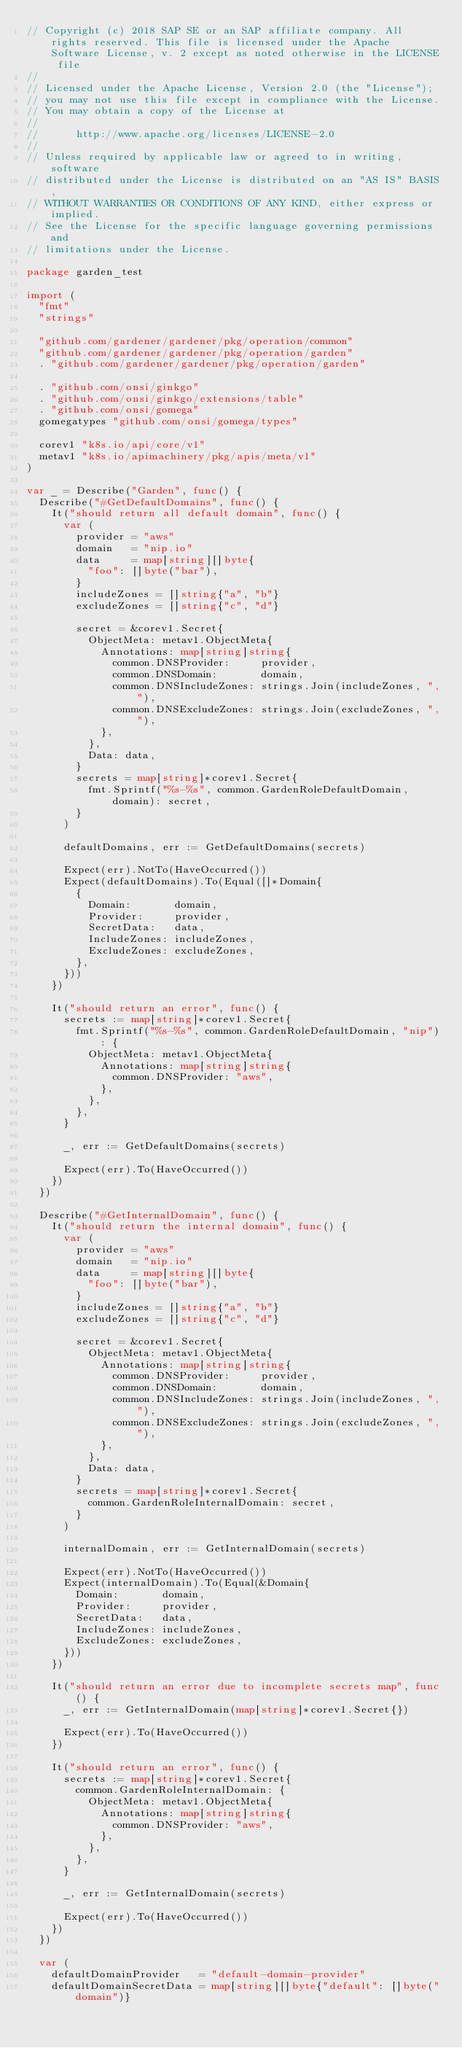<code> <loc_0><loc_0><loc_500><loc_500><_Go_>// Copyright (c) 2018 SAP SE or an SAP affiliate company. All rights reserved. This file is licensed under the Apache Software License, v. 2 except as noted otherwise in the LICENSE file
//
// Licensed under the Apache License, Version 2.0 (the "License");
// you may not use this file except in compliance with the License.
// You may obtain a copy of the License at
//
//      http://www.apache.org/licenses/LICENSE-2.0
//
// Unless required by applicable law or agreed to in writing, software
// distributed under the License is distributed on an "AS IS" BASIS,
// WITHOUT WARRANTIES OR CONDITIONS OF ANY KIND, either express or implied.
// See the License for the specific language governing permissions and
// limitations under the License.

package garden_test

import (
	"fmt"
	"strings"

	"github.com/gardener/gardener/pkg/operation/common"
	"github.com/gardener/gardener/pkg/operation/garden"
	. "github.com/gardener/gardener/pkg/operation/garden"

	. "github.com/onsi/ginkgo"
	. "github.com/onsi/ginkgo/extensions/table"
	. "github.com/onsi/gomega"
	gomegatypes "github.com/onsi/gomega/types"

	corev1 "k8s.io/api/core/v1"
	metav1 "k8s.io/apimachinery/pkg/apis/meta/v1"
)

var _ = Describe("Garden", func() {
	Describe("#GetDefaultDomains", func() {
		It("should return all default domain", func() {
			var (
				provider = "aws"
				domain   = "nip.io"
				data     = map[string][]byte{
					"foo": []byte("bar"),
				}
				includeZones = []string{"a", "b"}
				excludeZones = []string{"c", "d"}

				secret = &corev1.Secret{
					ObjectMeta: metav1.ObjectMeta{
						Annotations: map[string]string{
							common.DNSProvider:     provider,
							common.DNSDomain:       domain,
							common.DNSIncludeZones: strings.Join(includeZones, ","),
							common.DNSExcludeZones: strings.Join(excludeZones, ","),
						},
					},
					Data: data,
				}
				secrets = map[string]*corev1.Secret{
					fmt.Sprintf("%s-%s", common.GardenRoleDefaultDomain, domain): secret,
				}
			)

			defaultDomains, err := GetDefaultDomains(secrets)

			Expect(err).NotTo(HaveOccurred())
			Expect(defaultDomains).To(Equal([]*Domain{
				{
					Domain:       domain,
					Provider:     provider,
					SecretData:   data,
					IncludeZones: includeZones,
					ExcludeZones: excludeZones,
				},
			}))
		})

		It("should return an error", func() {
			secrets := map[string]*corev1.Secret{
				fmt.Sprintf("%s-%s", common.GardenRoleDefaultDomain, "nip"): {
					ObjectMeta: metav1.ObjectMeta{
						Annotations: map[string]string{
							common.DNSProvider: "aws",
						},
					},
				},
			}

			_, err := GetDefaultDomains(secrets)

			Expect(err).To(HaveOccurred())
		})
	})

	Describe("#GetInternalDomain", func() {
		It("should return the internal domain", func() {
			var (
				provider = "aws"
				domain   = "nip.io"
				data     = map[string][]byte{
					"foo": []byte("bar"),
				}
				includeZones = []string{"a", "b"}
				excludeZones = []string{"c", "d"}

				secret = &corev1.Secret{
					ObjectMeta: metav1.ObjectMeta{
						Annotations: map[string]string{
							common.DNSProvider:     provider,
							common.DNSDomain:       domain,
							common.DNSIncludeZones: strings.Join(includeZones, ","),
							common.DNSExcludeZones: strings.Join(excludeZones, ","),
						},
					},
					Data: data,
				}
				secrets = map[string]*corev1.Secret{
					common.GardenRoleInternalDomain: secret,
				}
			)

			internalDomain, err := GetInternalDomain(secrets)

			Expect(err).NotTo(HaveOccurred())
			Expect(internalDomain).To(Equal(&Domain{
				Domain:       domain,
				Provider:     provider,
				SecretData:   data,
				IncludeZones: includeZones,
				ExcludeZones: excludeZones,
			}))
		})

		It("should return an error due to incomplete secrets map", func() {
			_, err := GetInternalDomain(map[string]*corev1.Secret{})

			Expect(err).To(HaveOccurred())
		})

		It("should return an error", func() {
			secrets := map[string]*corev1.Secret{
				common.GardenRoleInternalDomain: {
					ObjectMeta: metav1.ObjectMeta{
						Annotations: map[string]string{
							common.DNSProvider: "aws",
						},
					},
				},
			}

			_, err := GetInternalDomain(secrets)

			Expect(err).To(HaveOccurred())
		})
	})

	var (
		defaultDomainProvider   = "default-domain-provider"
		defaultDomainSecretData = map[string][]byte{"default": []byte("domain")}</code> 